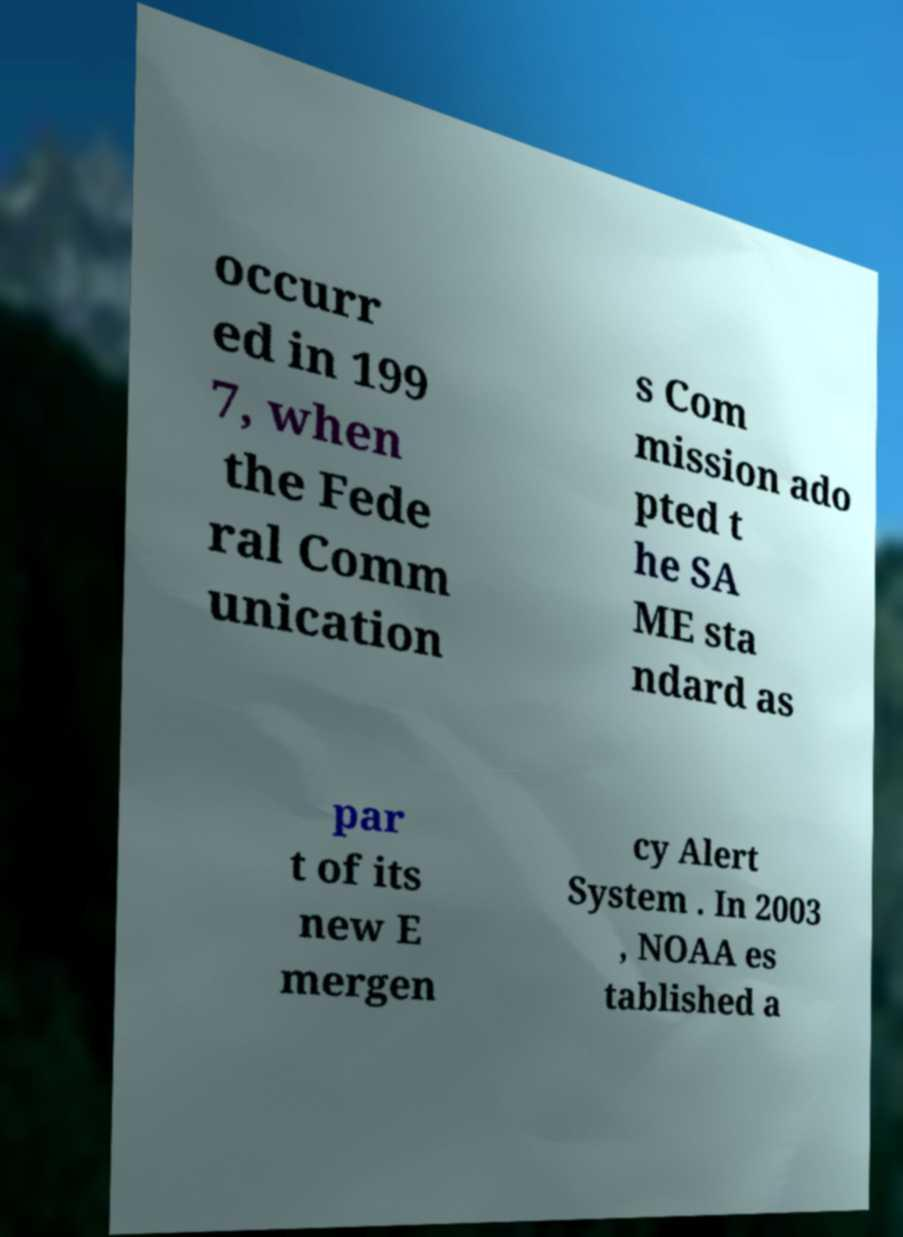Could you extract and type out the text from this image? occurr ed in 199 7, when the Fede ral Comm unication s Com mission ado pted t he SA ME sta ndard as par t of its new E mergen cy Alert System . In 2003 , NOAA es tablished a 